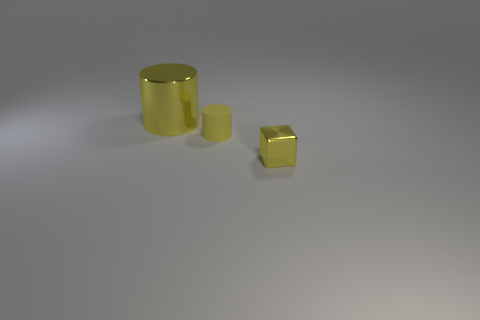There is a large thing; is it the same color as the tiny matte cylinder that is to the left of the yellow metal cube?
Your response must be concise. Yes. There is a tiny thing to the left of the object in front of the tiny thing behind the block; what is its shape?
Your response must be concise. Cylinder. Is the number of yellow metal cylinders that are to the left of the small cylinder greater than the number of tiny cyan balls?
Make the answer very short. Yes. There is a small yellow matte thing; does it have the same shape as the yellow thing to the left of the small rubber cylinder?
Make the answer very short. Yes. What shape is the large metal thing that is the same color as the small shiny thing?
Your answer should be compact. Cylinder. There is a metallic thing that is behind the yellow cylinder in front of the yellow shiny cylinder; what number of yellow rubber cylinders are on the left side of it?
Ensure brevity in your answer.  0. What color is the shiny cube that is the same size as the rubber cylinder?
Ensure brevity in your answer.  Yellow. There is a yellow shiny object that is left of the tiny yellow thing in front of the rubber cylinder; what is its size?
Provide a short and direct response. Large. There is another cylinder that is the same color as the rubber cylinder; what is its size?
Your answer should be very brief. Large. How many other objects are there of the same size as the matte cylinder?
Your answer should be compact. 1. 